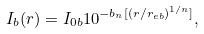Convert formula to latex. <formula><loc_0><loc_0><loc_500><loc_500>I _ { b } ( r ) = I _ { 0 b } 1 0 ^ { - b _ { n } [ ( r / r _ { e b } ) ^ { 1 / n } ] } ,</formula> 